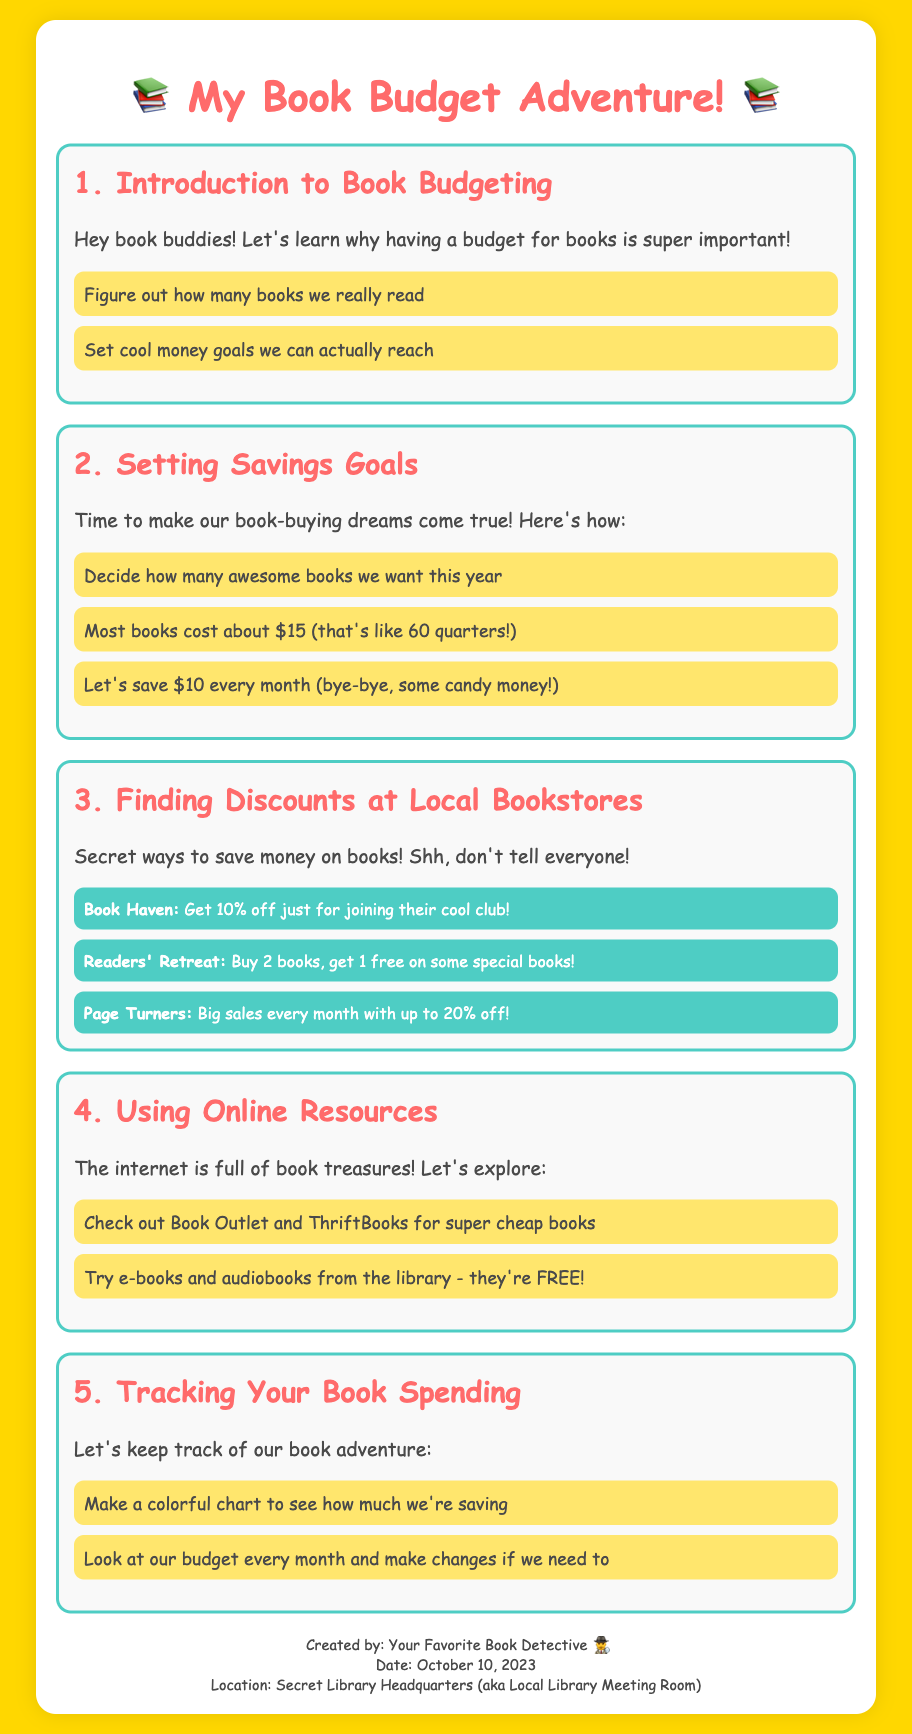What is the title of the document? The title of the document is stated prominently at the top.
Answer: My Book Budget Adventure! What is the cost of most books mentioned? The document indicates a specific price point for most books.
Answer: $15 How much do we plan to save each month? The savings goal is explicitly stated in the budgeting section.
Answer: $10 What discount do you get at Book Haven for joining their club? The document provides a specific percentage discount for a bookstore.
Answer: 10% What is the maximum discount offered at Page Turners? The maximum discount for a specific bookstore is mentioned.
Answer: 20% How many books can you get for the price of two at Readers' Retreat? The document outlines a specific promotional offer at a bookstore.
Answer: 3 books What kind of resources can help us find cheap books online? The document mentions specific online platforms for finding inexpensive books.
Answer: Book Outlet and ThriftBooks What should we do each month to track our book spending? The document suggests an activity to monitor spending.
Answer: Make a colorful chart 